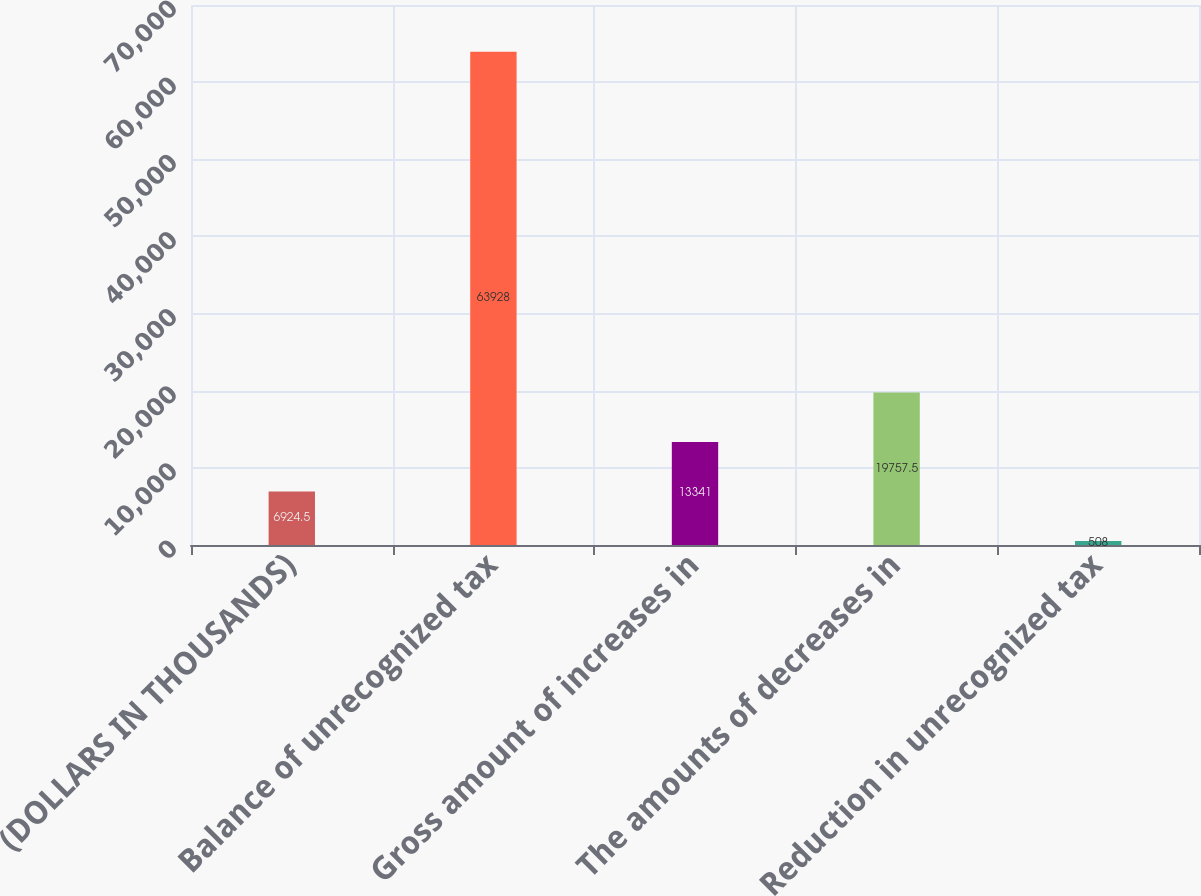<chart> <loc_0><loc_0><loc_500><loc_500><bar_chart><fcel>(DOLLARS IN THOUSANDS)<fcel>Balance of unrecognized tax<fcel>Gross amount of increases in<fcel>The amounts of decreases in<fcel>Reduction in unrecognized tax<nl><fcel>6924.5<fcel>63928<fcel>13341<fcel>19757.5<fcel>508<nl></chart> 